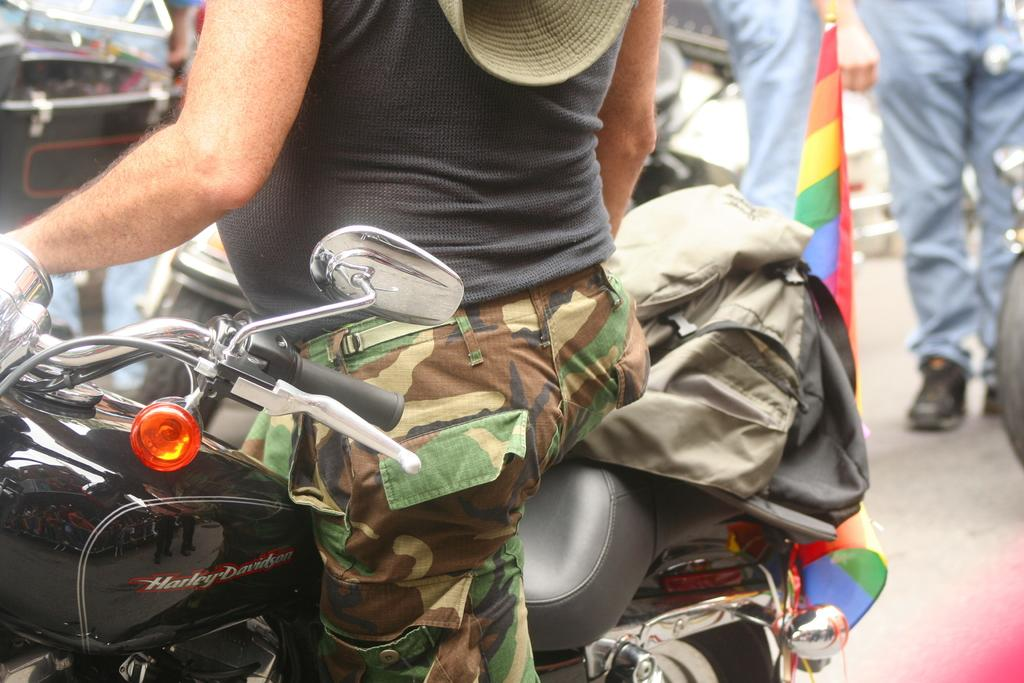What is the main subject of the image? There is a person in the image. What is the person doing in the image? The person is on a bike. Can you describe the background of the image? There are people visible in the background of the image. What type of wound can be seen on the person's leg in the image? There is no wound visible on the person's leg in the image. What sound does the person make while riding the bike in the image? The image does not provide any information about sounds, so we cannot determine if the person is making any sounds while riding the bike. 